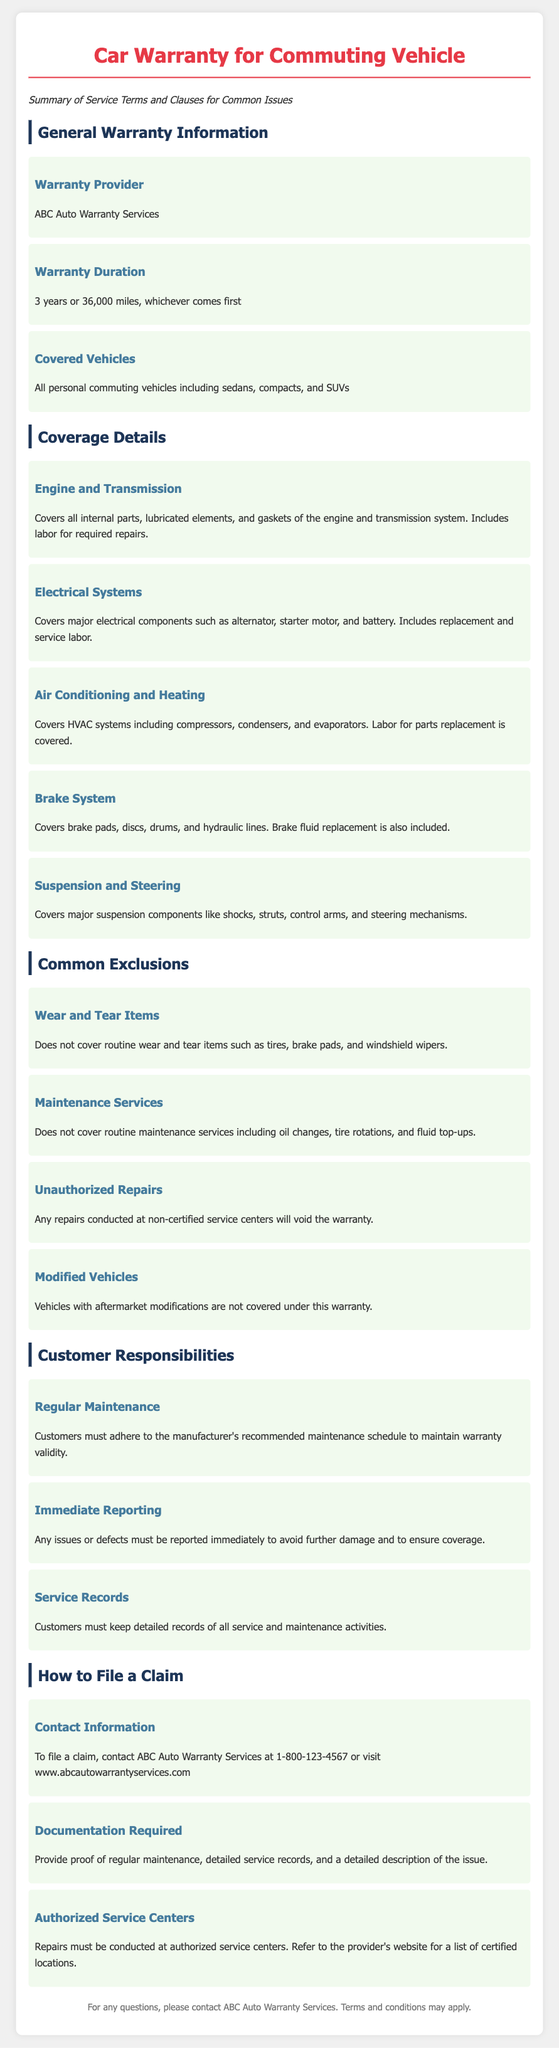What is the warranty provider? The warranty provider is mentioned in the document under General Warranty Information.
Answer: ABC Auto Warranty Services What is the warranty duration? The duration of the warranty is specified in the document under General Warranty Information.
Answer: 3 years or 36,000 miles What types of vehicles are covered? The document lists the types of vehicles covered under the warranty in the General Warranty Information section.
Answer: All personal commuting vehicles What major electrical components are covered? The document details various components covered regarding Electrical Systems in Coverage Details.
Answer: Alternator, starter motor, and battery What is not covered under Wear and Tear Items? The document specifies items not covered under Common Exclusions, particularly focusing on wear and tear.
Answer: Tires, brake pads, and windshield wipers What must customers keep to maintain warranty validity? The section on Customer Responsibilities states what customers are required to maintain.
Answer: Detailed records of all service and maintenance activities How can a customer file a claim? The procedure for filing a claim is outlined in the 'How to File a Claim' section.
Answer: Contact ABC Auto Warranty Services at 1-800-123-4567 What should be provided as documentation for a claim? The documentation required to file a claim is listed in the claims section of the document.
Answer: Proof of regular maintenance, detailed service records, and a detailed description of the issue What happens if repairs are conducted at non-certified service centers? The consequences of using non-certified centers are specified in the document under Common Exclusions.
Answer: Will void the warranty 